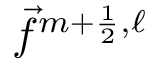Convert formula to latex. <formula><loc_0><loc_0><loc_500><loc_500>\vec { f } ^ { m + \frac { 1 } { 2 } , \ell }</formula> 